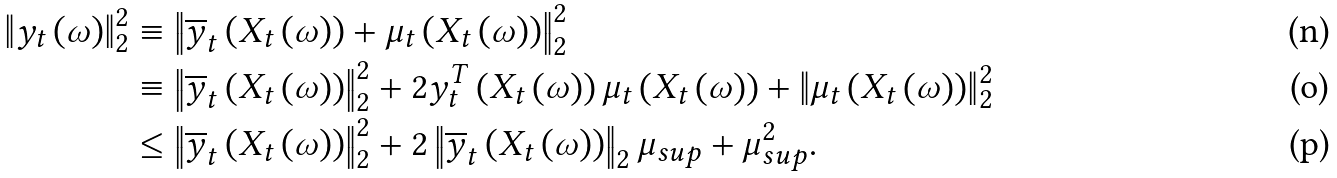<formula> <loc_0><loc_0><loc_500><loc_500>\left \| { y } _ { t } \left ( \omega \right ) \right \| _ { 2 } ^ { 2 } & \equiv \left \| \overline { y } _ { t } \left ( X _ { t } \left ( \omega \right ) \right ) + \mu _ { t } \left ( X _ { t } \left ( \omega \right ) \right ) \right \| _ { 2 } ^ { 2 } \\ & \equiv \left \| \overline { y } _ { t } \left ( X _ { t } \left ( \omega \right ) \right ) \right \| _ { 2 } ^ { 2 } + 2 { y } _ { t } ^ { T } \left ( X _ { t } \left ( \omega \right ) \right ) \mu _ { t } \left ( X _ { t } \left ( \omega \right ) \right ) + \left \| \mu _ { t } \left ( X _ { t } \left ( \omega \right ) \right ) \right \| _ { 2 } ^ { 2 } \\ & \leq \left \| \overline { y } _ { t } \left ( X _ { t } \left ( \omega \right ) \right ) \right \| _ { 2 } ^ { 2 } + 2 \left \| \overline { y } _ { t } \left ( X _ { t } \left ( \omega \right ) \right ) \right \| _ { 2 } \mu _ { s u p } + \mu _ { s u p } ^ { 2 } .</formula> 